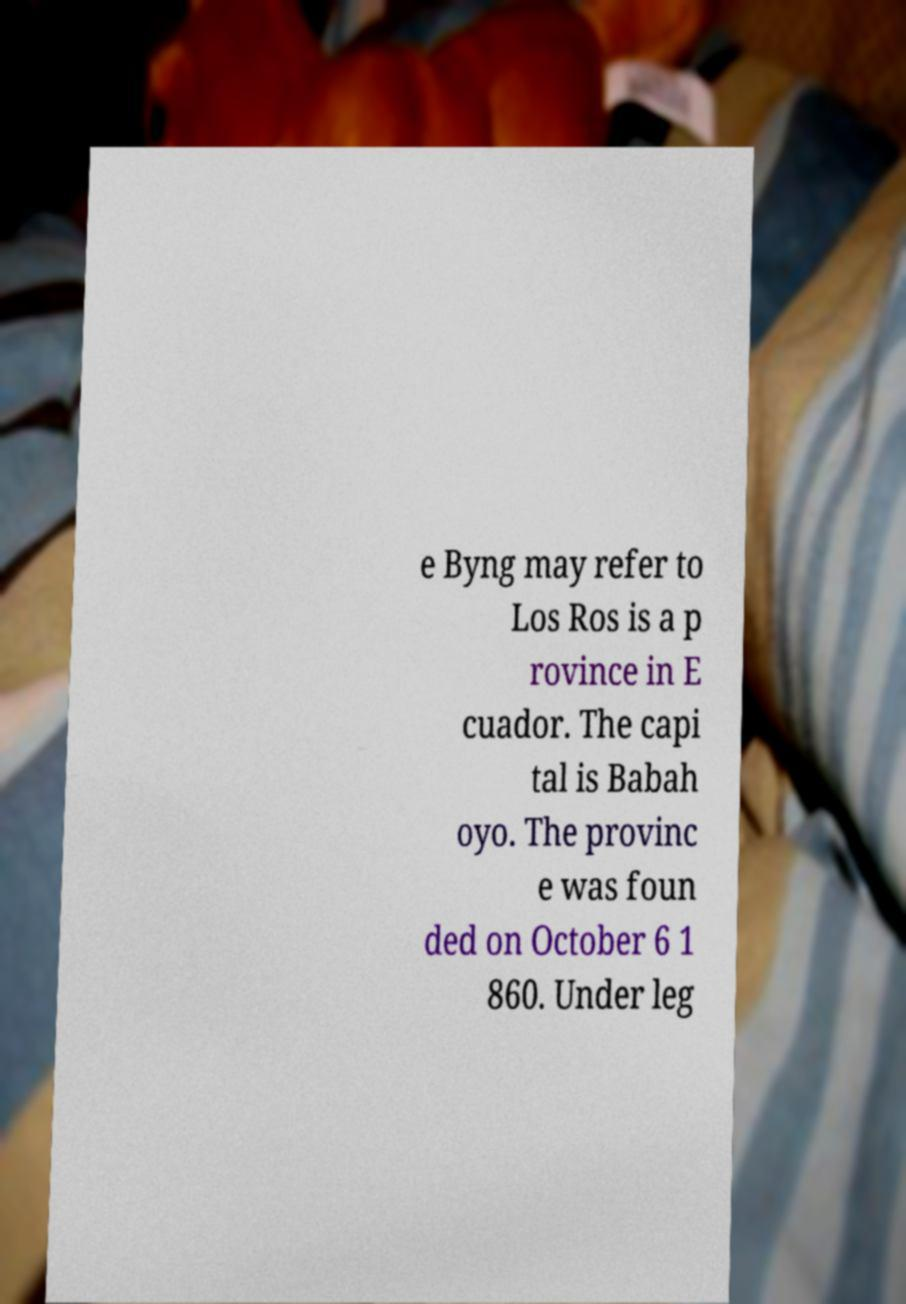Could you extract and type out the text from this image? e Byng may refer to Los Ros is a p rovince in E cuador. The capi tal is Babah oyo. The provinc e was foun ded on October 6 1 860. Under leg 